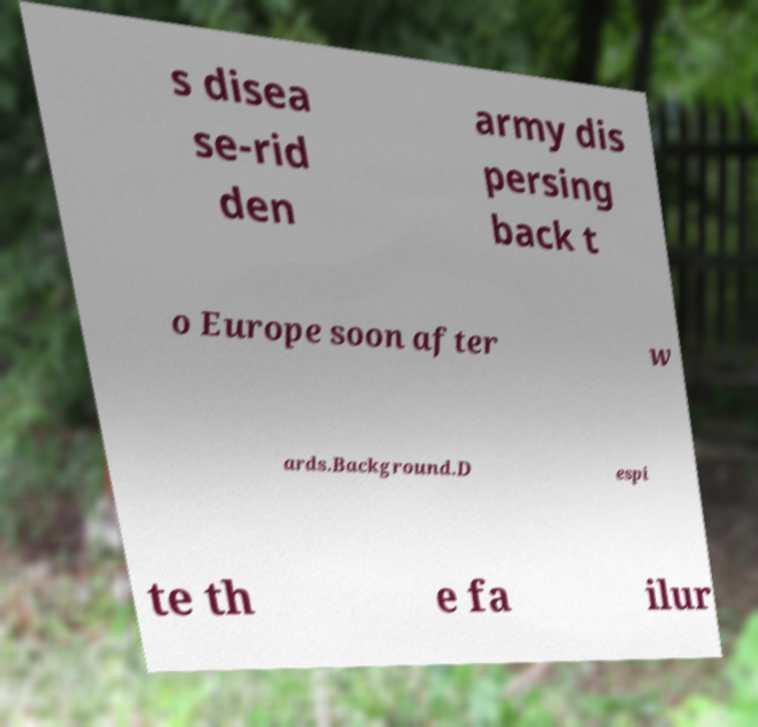For documentation purposes, I need the text within this image transcribed. Could you provide that? s disea se-rid den army dis persing back t o Europe soon after w ards.Background.D espi te th e fa ilur 